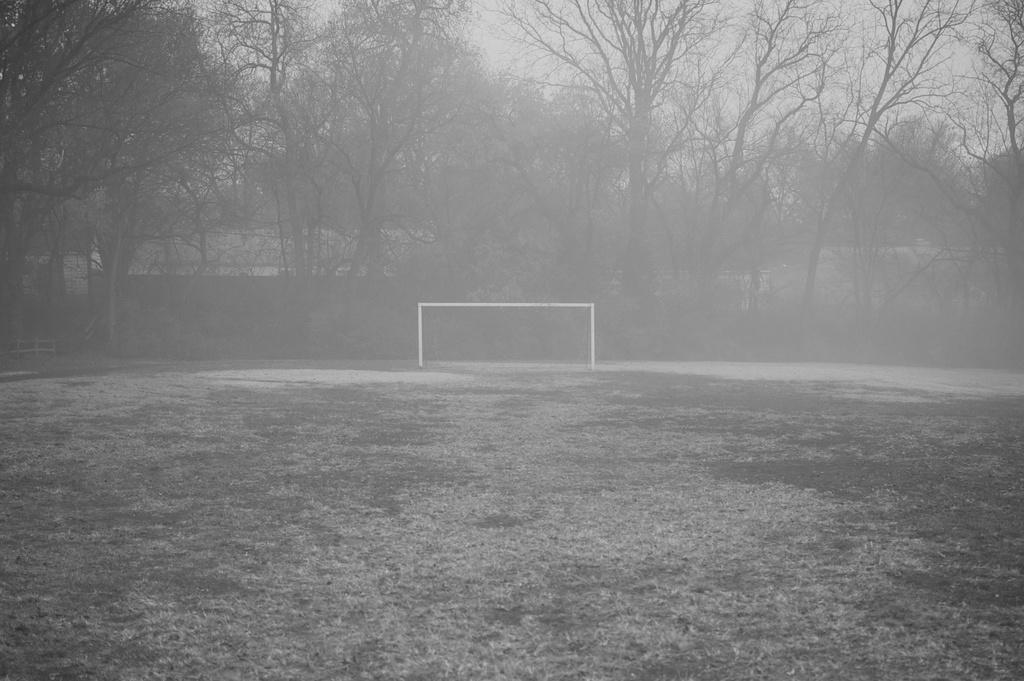What is the primary focus of the image? The image shows the ground. What can be seen on the ground in the image? There is a mesh on the ground in the image. What type of natural scenery is visible in the background of the image? There are trees in the background of the image. What else can be seen in the background of the image? The sky is visible in the background of the image. What type of silk is being used to create the mesh in the image? There is no silk present in the image; the mesh is not made of silk. 